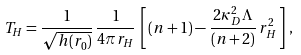Convert formula to latex. <formula><loc_0><loc_0><loc_500><loc_500>T _ { H } = \frac { 1 } { \sqrt { h ( r _ { 0 } ) } } \, \frac { 1 } { 4 \pi r _ { H } } \, \left [ \, ( n + 1 ) - \frac { 2 \kappa ^ { 2 } _ { D } \Lambda } { ( n + 2 ) } \, r _ { H } ^ { 2 } \, \right ] \, ,</formula> 